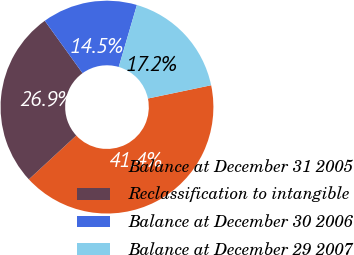Convert chart. <chart><loc_0><loc_0><loc_500><loc_500><pie_chart><fcel>Balance at December 31 2005<fcel>Reclassification to intangible<fcel>Balance at December 30 2006<fcel>Balance at December 29 2007<nl><fcel>41.42%<fcel>26.94%<fcel>14.47%<fcel>17.17%<nl></chart> 